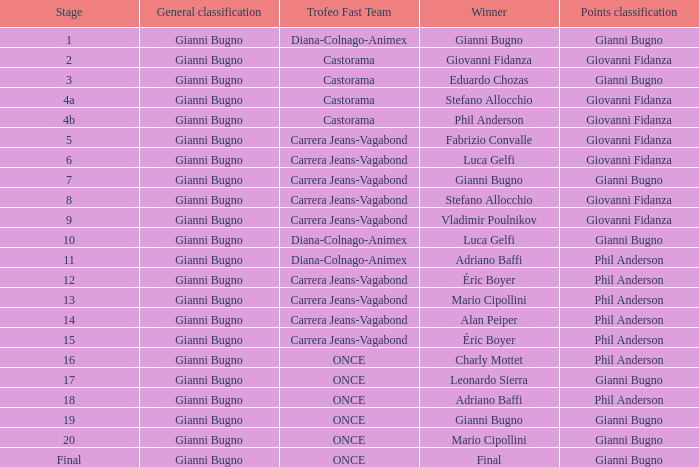Who is the trofeo fast team in stage 10? Diana-Colnago-Animex. 